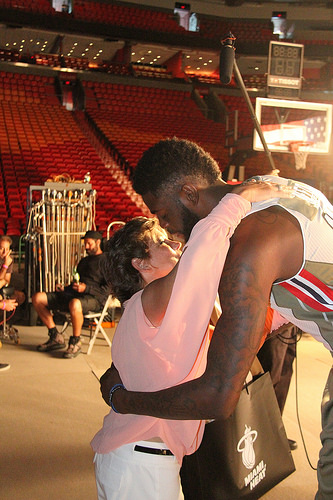<image>
Is there a shirt on the man? Yes. Looking at the image, I can see the shirt is positioned on top of the man, with the man providing support. Is the woman to the left of the man? Yes. From this viewpoint, the woman is positioned to the left side relative to the man. 